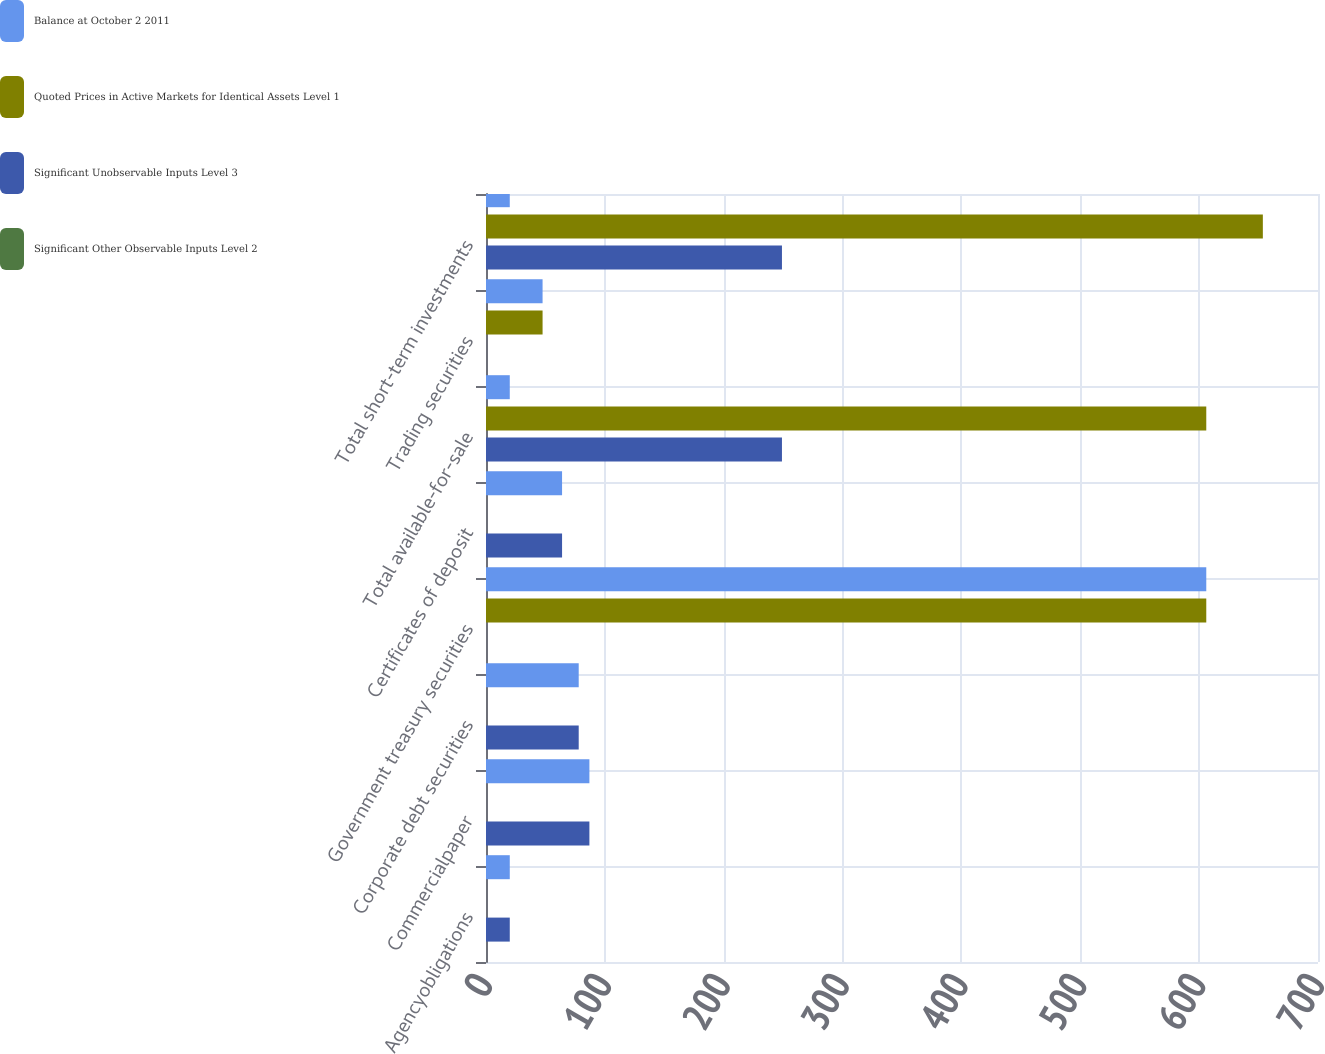Convert chart. <chart><loc_0><loc_0><loc_500><loc_500><stacked_bar_chart><ecel><fcel>Agencyobligations<fcel>Commercialpaper<fcel>Corporate debt securities<fcel>Government treasury securities<fcel>Certificates of deposit<fcel>Total available-for-sale<fcel>Trading securities<fcel>Total short-term investments<nl><fcel>Balance at October 2 2011<fcel>20<fcel>87<fcel>78<fcel>606<fcel>64<fcel>20<fcel>47.6<fcel>20<nl><fcel>Quoted Prices in Active Markets for Identical Assets Level 1<fcel>0<fcel>0<fcel>0<fcel>606<fcel>0<fcel>606<fcel>47.6<fcel>653.6<nl><fcel>Significant Unobservable Inputs Level 3<fcel>20<fcel>87<fcel>78<fcel>0<fcel>64<fcel>249<fcel>0<fcel>249<nl><fcel>Significant Other Observable Inputs Level 2<fcel>0<fcel>0<fcel>0<fcel>0<fcel>0<fcel>0<fcel>0<fcel>0<nl></chart> 